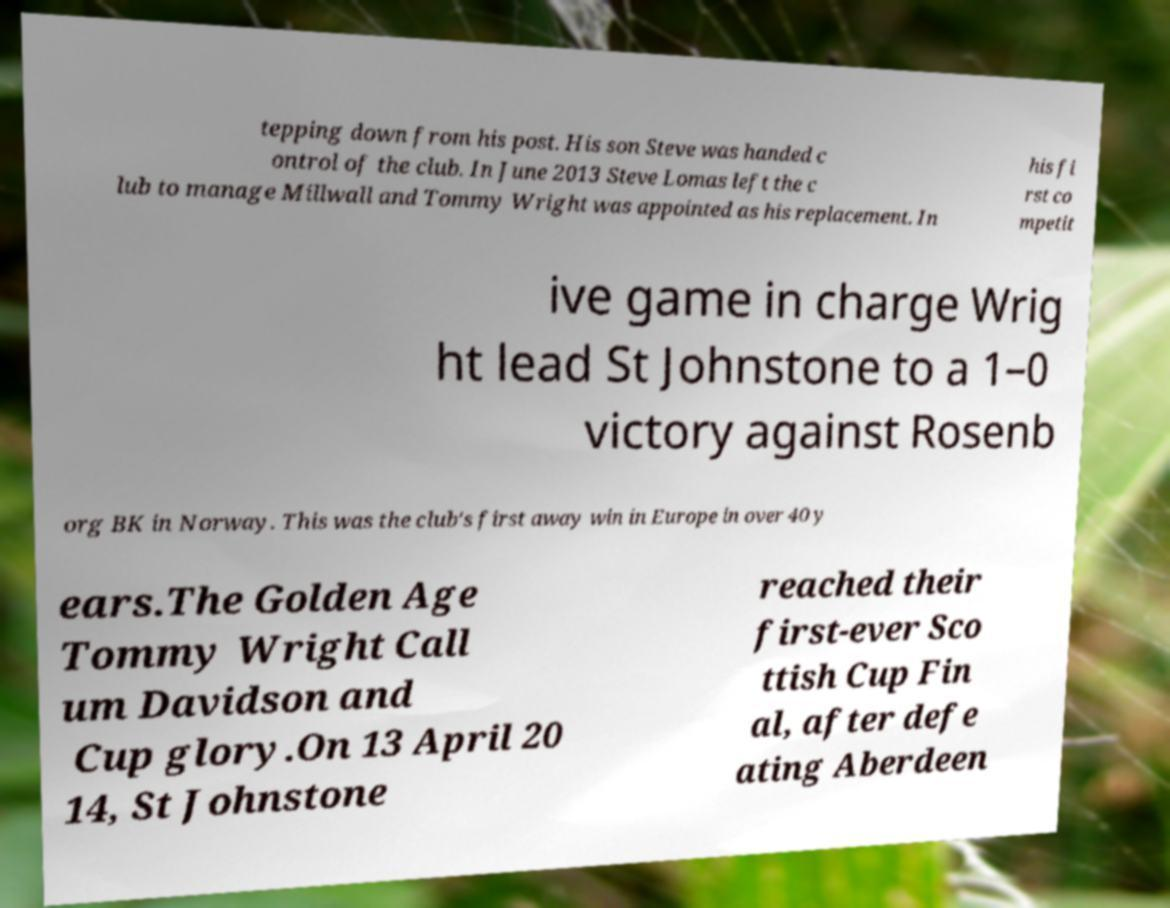I need the written content from this picture converted into text. Can you do that? tepping down from his post. His son Steve was handed c ontrol of the club. In June 2013 Steve Lomas left the c lub to manage Millwall and Tommy Wright was appointed as his replacement. In his fi rst co mpetit ive game in charge Wrig ht lead St Johnstone to a 1–0 victory against Rosenb org BK in Norway. This was the club's first away win in Europe in over 40 y ears.The Golden Age Tommy Wright Call um Davidson and Cup glory.On 13 April 20 14, St Johnstone reached their first-ever Sco ttish Cup Fin al, after defe ating Aberdeen 